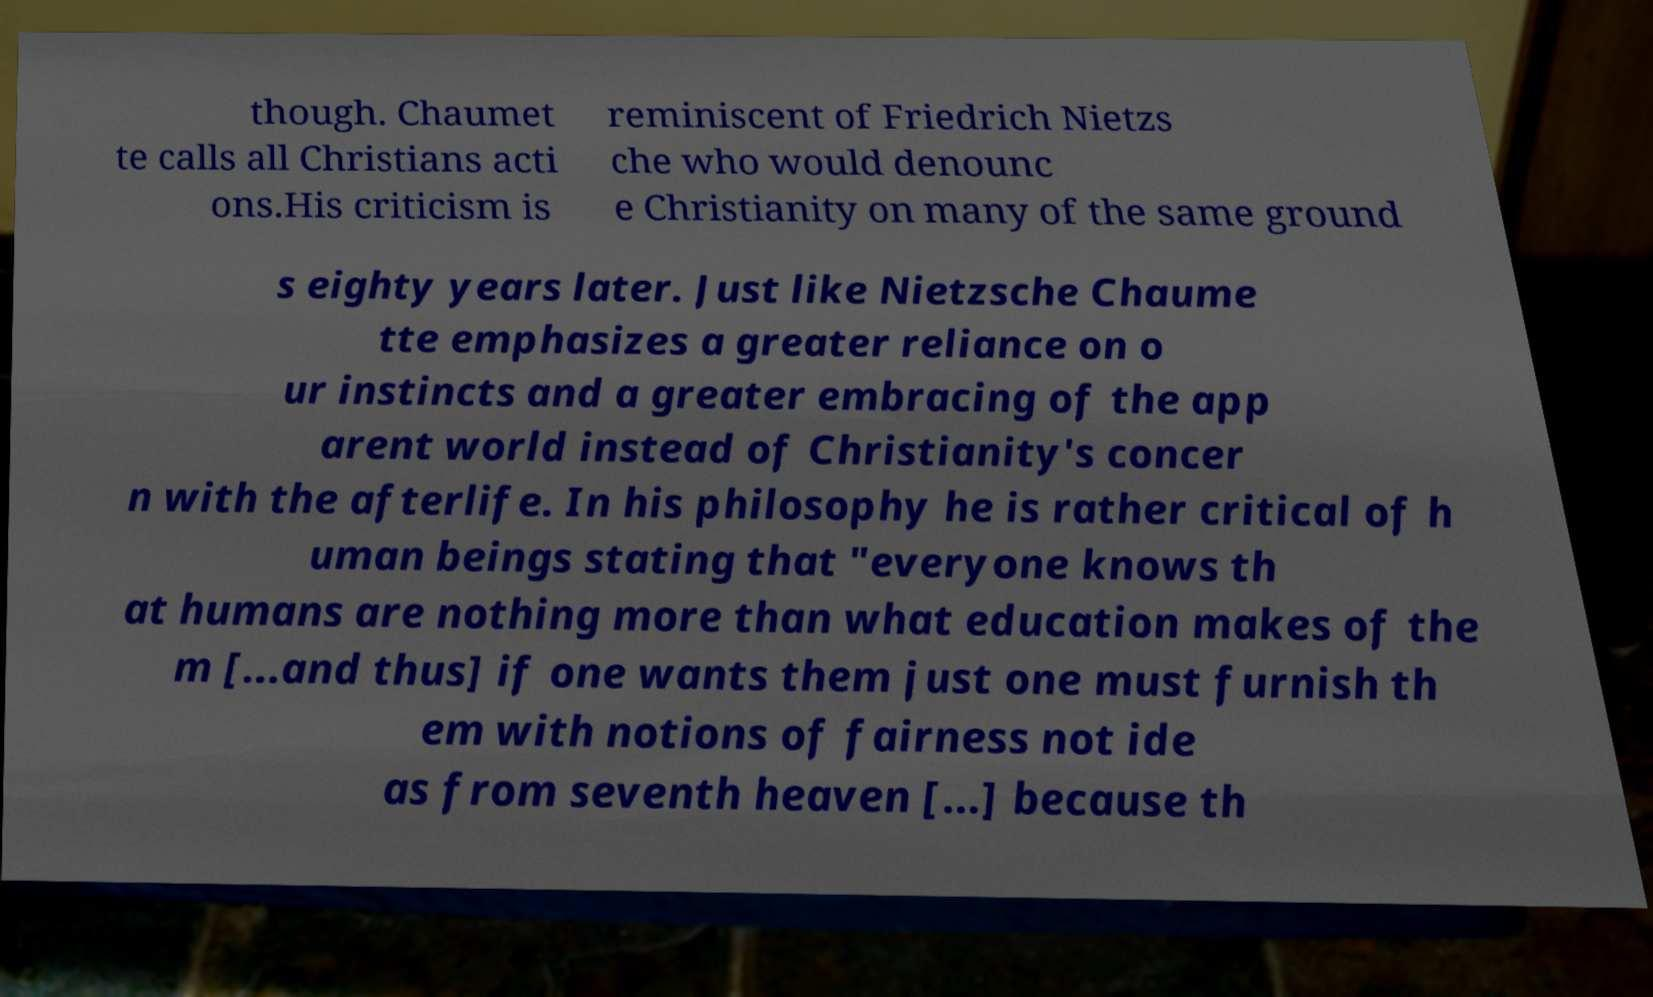For documentation purposes, I need the text within this image transcribed. Could you provide that? though. Chaumet te calls all Christians acti ons.His criticism is reminiscent of Friedrich Nietzs che who would denounc e Christianity on many of the same ground s eighty years later. Just like Nietzsche Chaume tte emphasizes a greater reliance on o ur instincts and a greater embracing of the app arent world instead of Christianity's concer n with the afterlife. In his philosophy he is rather critical of h uman beings stating that "everyone knows th at humans are nothing more than what education makes of the m [...and thus] if one wants them just one must furnish th em with notions of fairness not ide as from seventh heaven [...] because th 